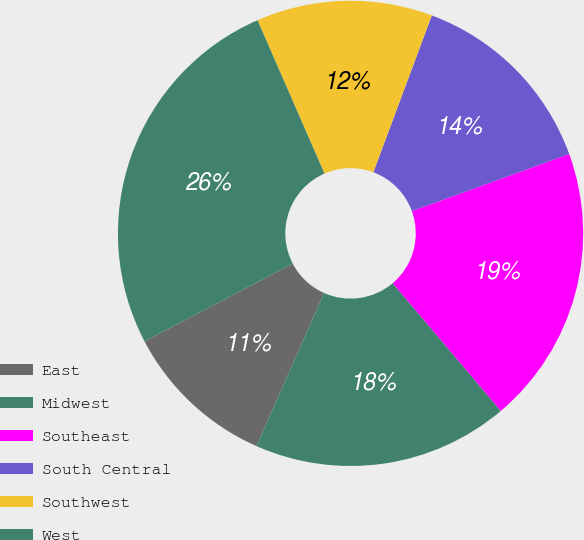Convert chart. <chart><loc_0><loc_0><loc_500><loc_500><pie_chart><fcel>East<fcel>Midwest<fcel>Southeast<fcel>South Central<fcel>Southwest<fcel>West<nl><fcel>10.69%<fcel>17.81%<fcel>19.36%<fcel>13.78%<fcel>12.23%<fcel>26.13%<nl></chart> 